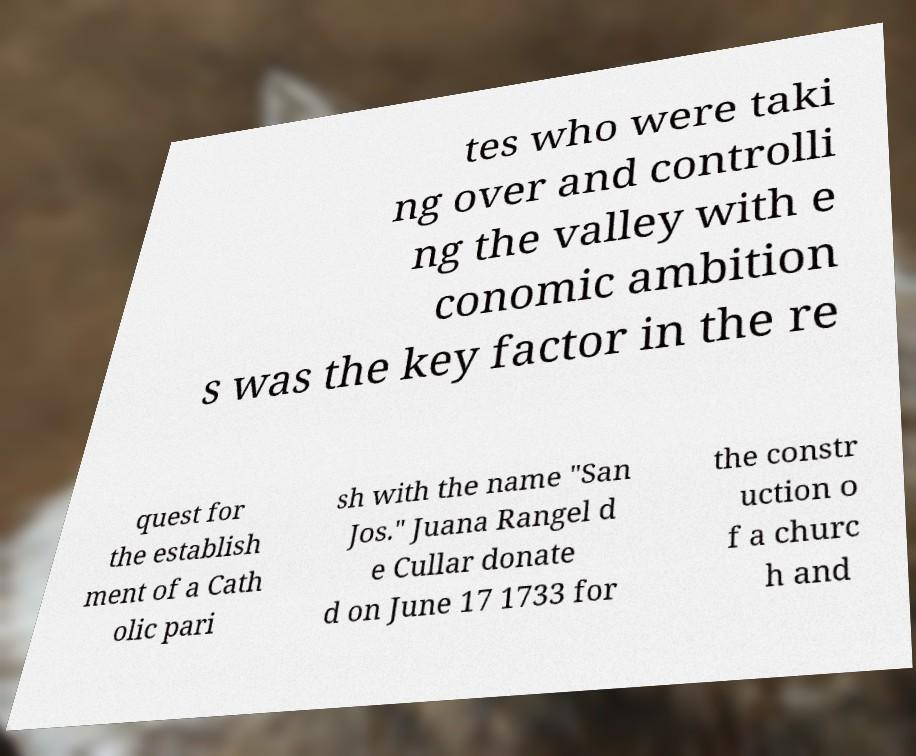For documentation purposes, I need the text within this image transcribed. Could you provide that? tes who were taki ng over and controlli ng the valley with e conomic ambition s was the key factor in the re quest for the establish ment of a Cath olic pari sh with the name "San Jos." Juana Rangel d e Cullar donate d on June 17 1733 for the constr uction o f a churc h and 